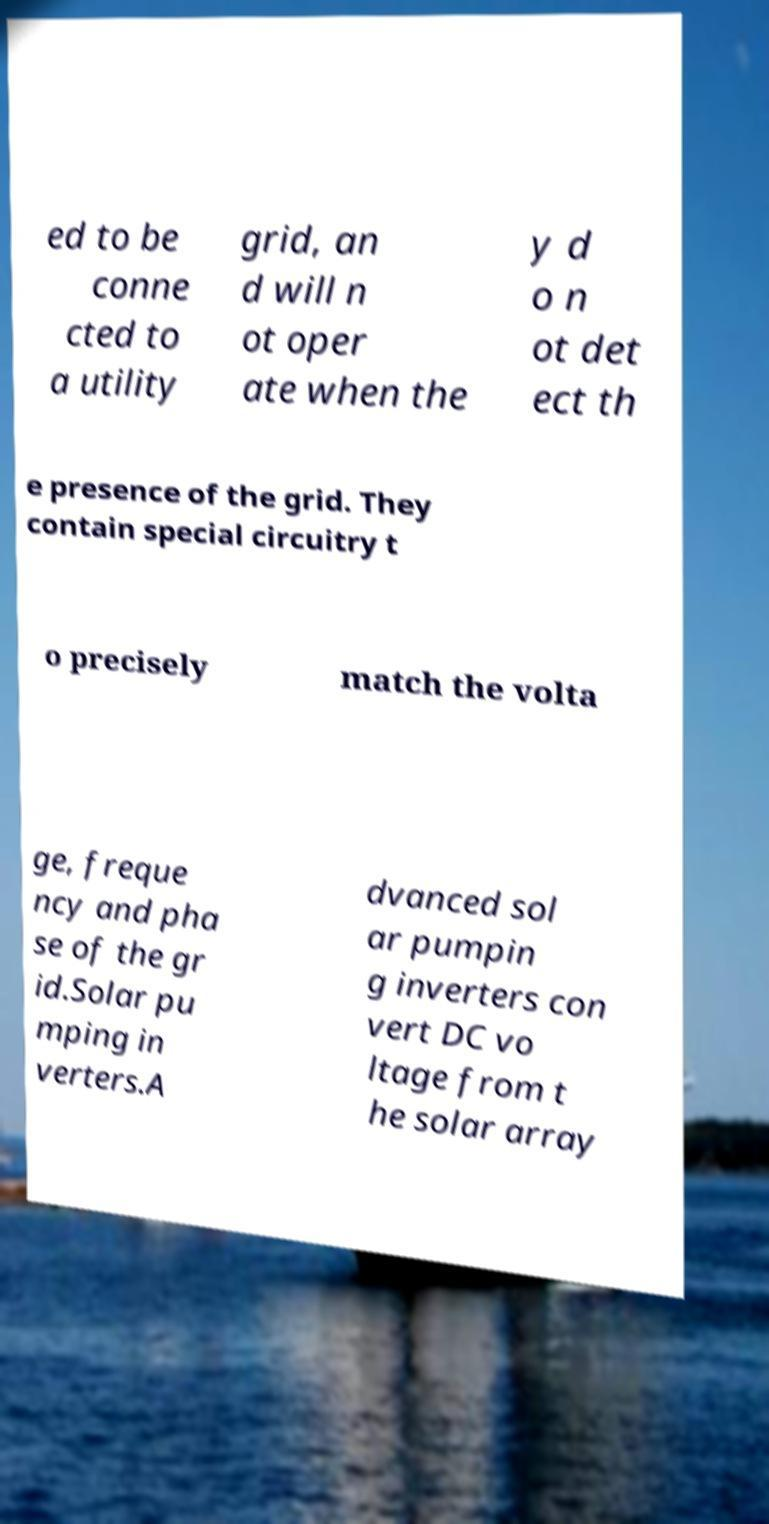Could you assist in decoding the text presented in this image and type it out clearly? ed to be conne cted to a utility grid, an d will n ot oper ate when the y d o n ot det ect th e presence of the grid. They contain special circuitry t o precisely match the volta ge, freque ncy and pha se of the gr id.Solar pu mping in verters.A dvanced sol ar pumpin g inverters con vert DC vo ltage from t he solar array 